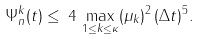<formula> <loc_0><loc_0><loc_500><loc_500>\Psi _ { n } ^ { k } ( t ) \leq \, 4 \, \max _ { 1 \leq { k } \leq \kappa } ( \mu _ { k } ) ^ { 2 } \, ( \Delta { t } ) ^ { 5 } .</formula> 